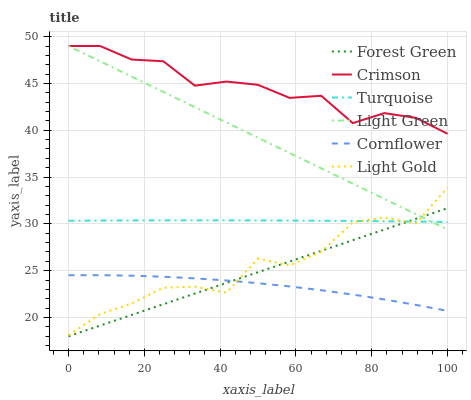Does Cornflower have the minimum area under the curve?
Answer yes or no. Yes. Does Crimson have the maximum area under the curve?
Answer yes or no. Yes. Does Turquoise have the minimum area under the curve?
Answer yes or no. No. Does Turquoise have the maximum area under the curve?
Answer yes or no. No. Is Forest Green the smoothest?
Answer yes or no. Yes. Is Light Gold the roughest?
Answer yes or no. Yes. Is Turquoise the smoothest?
Answer yes or no. No. Is Turquoise the roughest?
Answer yes or no. No. Does Forest Green have the lowest value?
Answer yes or no. Yes. Does Turquoise have the lowest value?
Answer yes or no. No. Does Crimson have the highest value?
Answer yes or no. Yes. Does Turquoise have the highest value?
Answer yes or no. No. Is Turquoise less than Crimson?
Answer yes or no. Yes. Is Crimson greater than Light Gold?
Answer yes or no. Yes. Does Light Green intersect Crimson?
Answer yes or no. Yes. Is Light Green less than Crimson?
Answer yes or no. No. Is Light Green greater than Crimson?
Answer yes or no. No. Does Turquoise intersect Crimson?
Answer yes or no. No. 